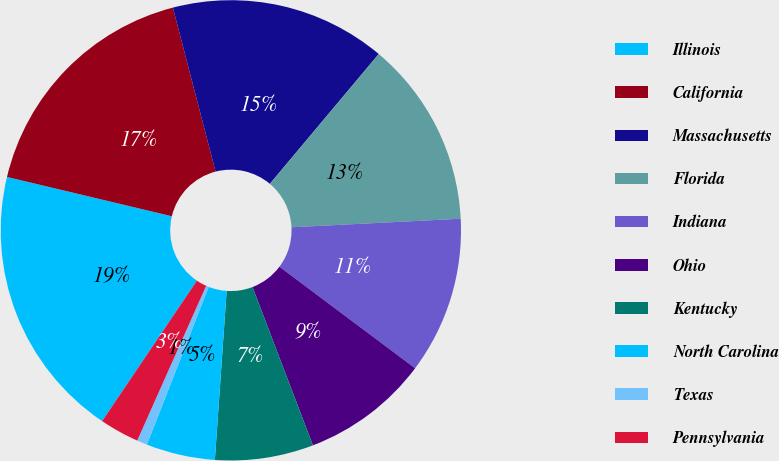Convert chart. <chart><loc_0><loc_0><loc_500><loc_500><pie_chart><fcel>Illinois<fcel>California<fcel>Massachusetts<fcel>Florida<fcel>Indiana<fcel>Ohio<fcel>Kentucky<fcel>North Carolina<fcel>Texas<fcel>Pennsylvania<nl><fcel>19.28%<fcel>17.22%<fcel>15.16%<fcel>13.09%<fcel>11.03%<fcel>8.97%<fcel>6.91%<fcel>4.84%<fcel>0.72%<fcel>2.78%<nl></chart> 